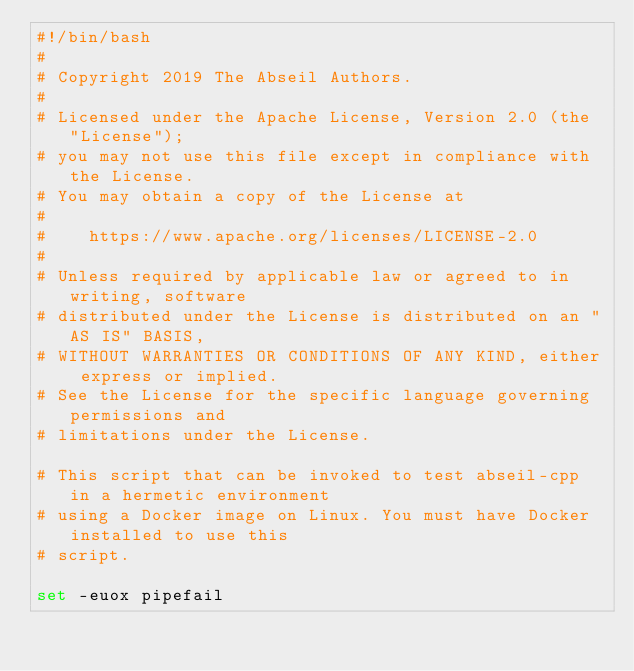Convert code to text. <code><loc_0><loc_0><loc_500><loc_500><_Bash_>#!/bin/bash
#
# Copyright 2019 The Abseil Authors.
#
# Licensed under the Apache License, Version 2.0 (the "License");
# you may not use this file except in compliance with the License.
# You may obtain a copy of the License at
#
#    https://www.apache.org/licenses/LICENSE-2.0
#
# Unless required by applicable law or agreed to in writing, software
# distributed under the License is distributed on an "AS IS" BASIS,
# WITHOUT WARRANTIES OR CONDITIONS OF ANY KIND, either express or implied.
# See the License for the specific language governing permissions and
# limitations under the License.

# This script that can be invoked to test abseil-cpp in a hermetic environment
# using a Docker image on Linux. You must have Docker installed to use this
# script.

set -euox pipefail
</code> 